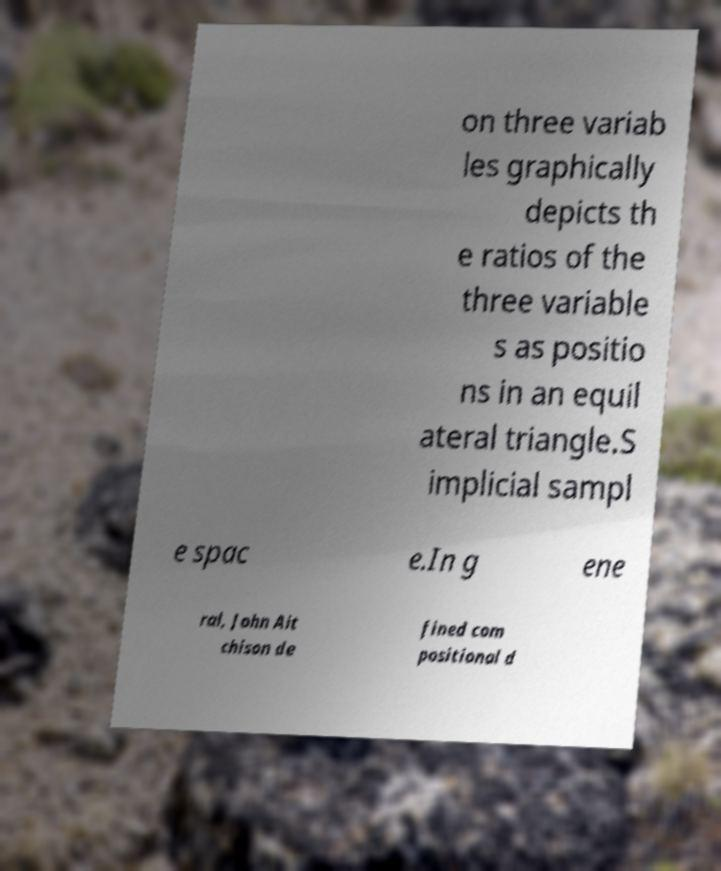I need the written content from this picture converted into text. Can you do that? on three variab les graphically depicts th e ratios of the three variable s as positio ns in an equil ateral triangle.S implicial sampl e spac e.In g ene ral, John Ait chison de fined com positional d 